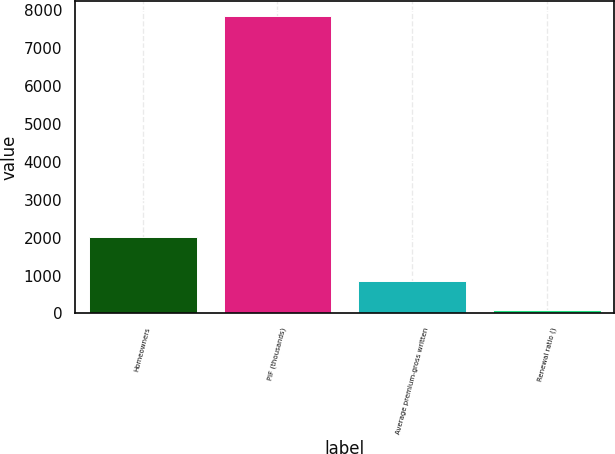Convert chart to OTSL. <chart><loc_0><loc_0><loc_500><loc_500><bar_chart><fcel>Homeowners<fcel>PIF (thousands)<fcel>Average premium-gross written<fcel>Renewal ratio ()<nl><fcel>2006<fcel>7836<fcel>862.17<fcel>87.3<nl></chart> 